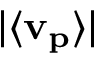<formula> <loc_0><loc_0><loc_500><loc_500>| \langle v _ { p } \rangle |</formula> 